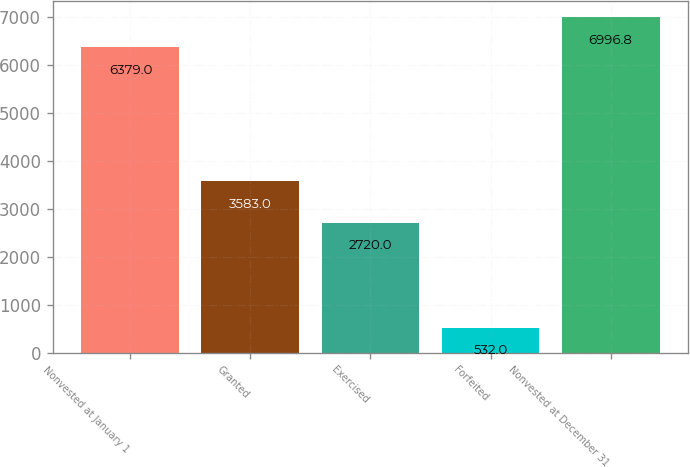Convert chart. <chart><loc_0><loc_0><loc_500><loc_500><bar_chart><fcel>Nonvested at January 1<fcel>Granted<fcel>Exercised<fcel>Forfeited<fcel>Nonvested at December 31<nl><fcel>6379<fcel>3583<fcel>2720<fcel>532<fcel>6996.8<nl></chart> 